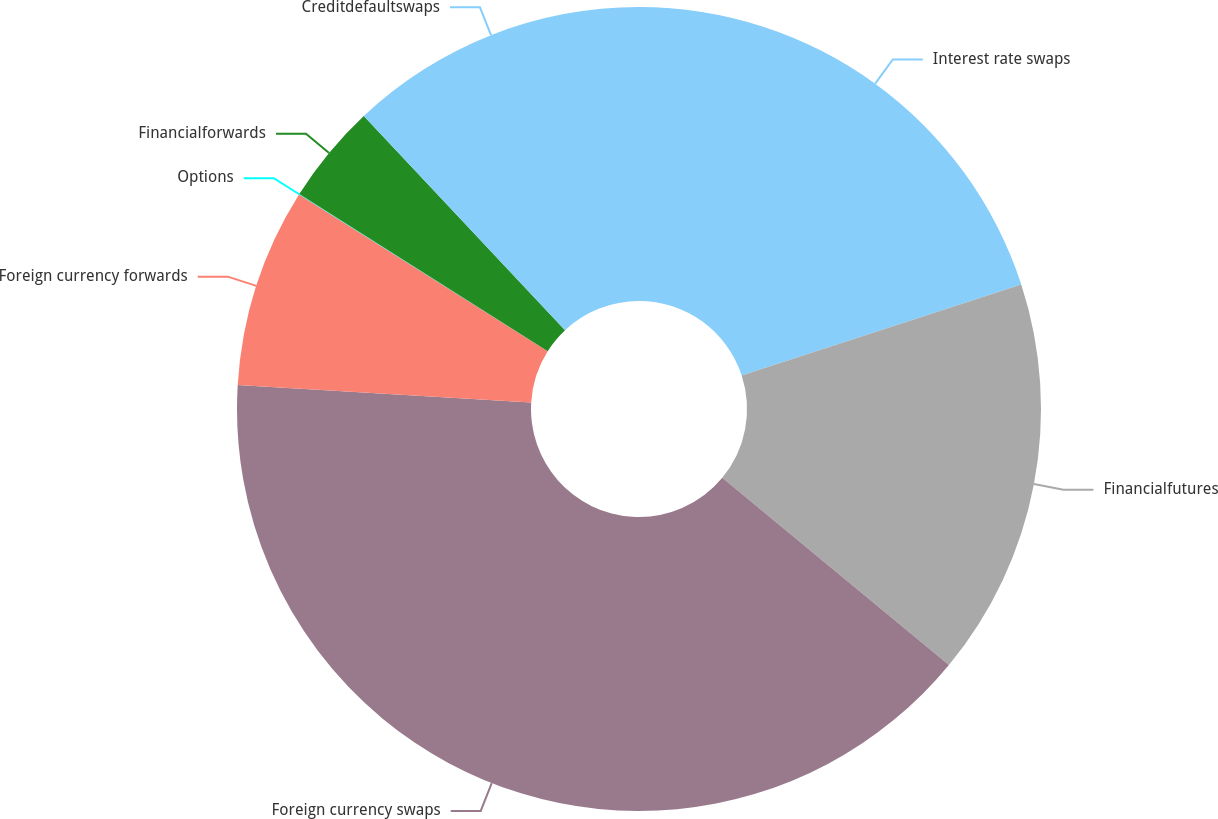Convert chart to OTSL. <chart><loc_0><loc_0><loc_500><loc_500><pie_chart><fcel>Interest rate swaps<fcel>Financialfutures<fcel>Foreign currency swaps<fcel>Foreign currency forwards<fcel>Options<fcel>Financialforwards<fcel>Creditdefaultswaps<nl><fcel>19.99%<fcel>16.0%<fcel>39.96%<fcel>8.01%<fcel>0.02%<fcel>4.02%<fcel>12.0%<nl></chart> 